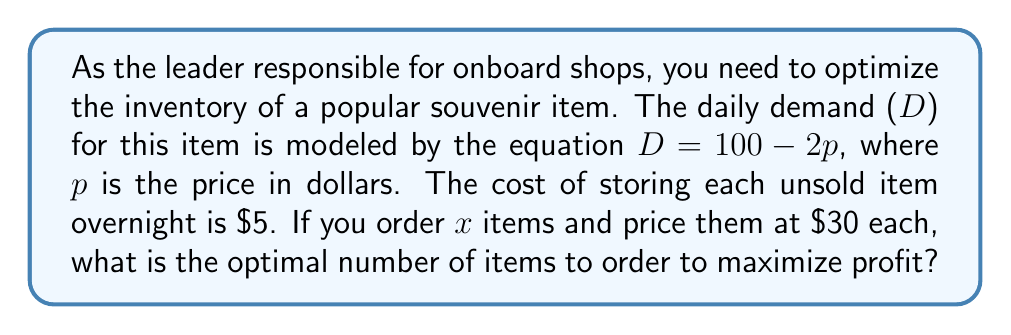What is the answer to this math problem? Let's approach this step-by-step:

1) First, we need to express the demand in terms of $x$:
   At $p = 30$, $D = 100 - 2(30) = 40$
   So, we expect to sell 40 items per day at this price.

2) Now, let's set up the profit function:
   Profit = Revenue - Cost
   $$ P(x) = 30 \min(x, 40) - 5(x - 40)^+ $$
   Where $(x - 40)^+$ means $\max(0, x - 40)$

3) This function has two parts:
   For $x \leq 40$: $P(x) = 30x$
   For $x > 40$: $P(x) = 1200 - 5(x - 40) = 1400 - 5x$

4) The maximum profit will occur either at $x = 40$ or where the derivative of the second part equals zero:
   $\frac{d}{dx}(1400 - 5x) = -5$
   This is always negative, so the profit decreases for $x > 40$

5) Therefore, the maximum profit occurs at $x = 40$
Answer: 40 items 